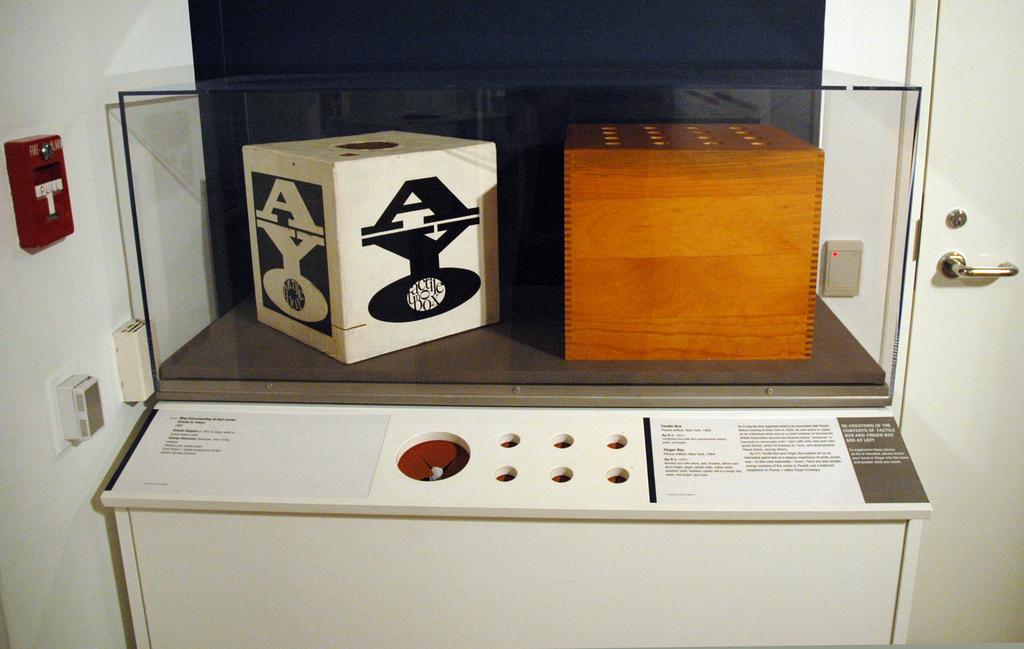What does the fire alarm say?
Give a very brief answer. Pull. What are the three letters shown of the left box?
Give a very brief answer. Ayo. 